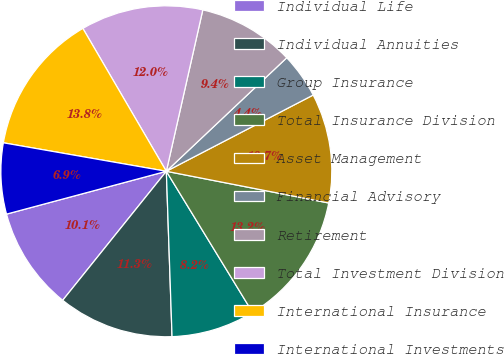Convert chart to OTSL. <chart><loc_0><loc_0><loc_500><loc_500><pie_chart><fcel>Individual Life<fcel>Individual Annuities<fcel>Group Insurance<fcel>Total Insurance Division<fcel>Asset Management<fcel>Financial Advisory<fcel>Retirement<fcel>Total Investment Division<fcel>International Insurance<fcel>International Investments<nl><fcel>10.06%<fcel>11.32%<fcel>8.18%<fcel>13.2%<fcel>10.69%<fcel>4.41%<fcel>9.43%<fcel>11.95%<fcel>13.83%<fcel>6.92%<nl></chart> 